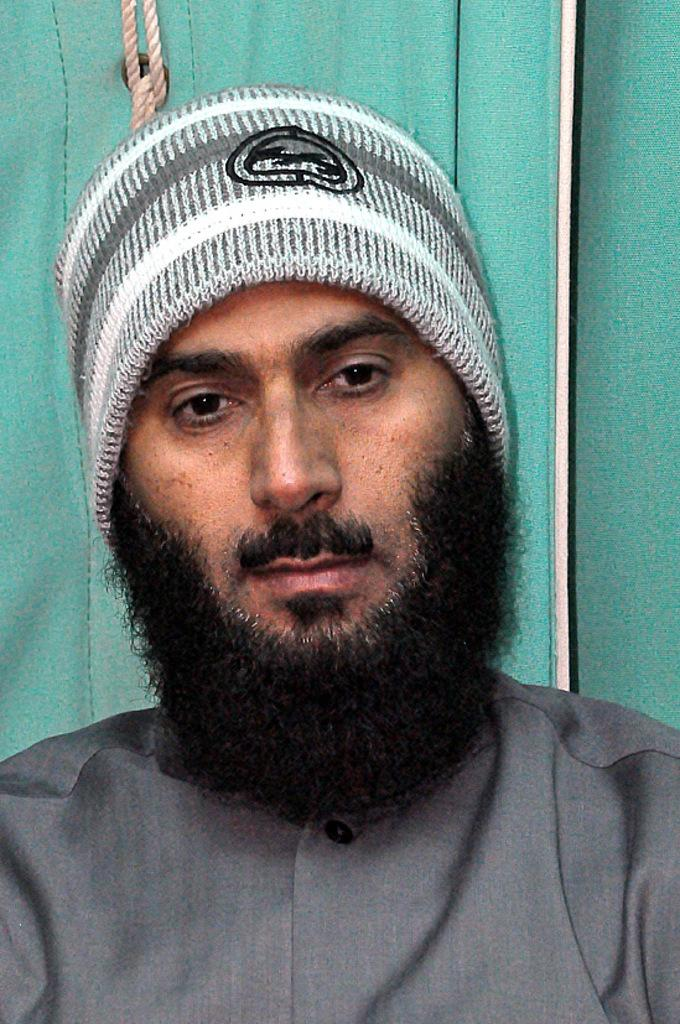Who or what is present in the image? There is a person in the image. What is the person wearing on their head? The person is wearing a hat. What other object can be seen in the image? There is a rope visible in the image. What is the opinion of the bear in the image? There is no bear present in the image, so it is not possible to determine its opinion. 